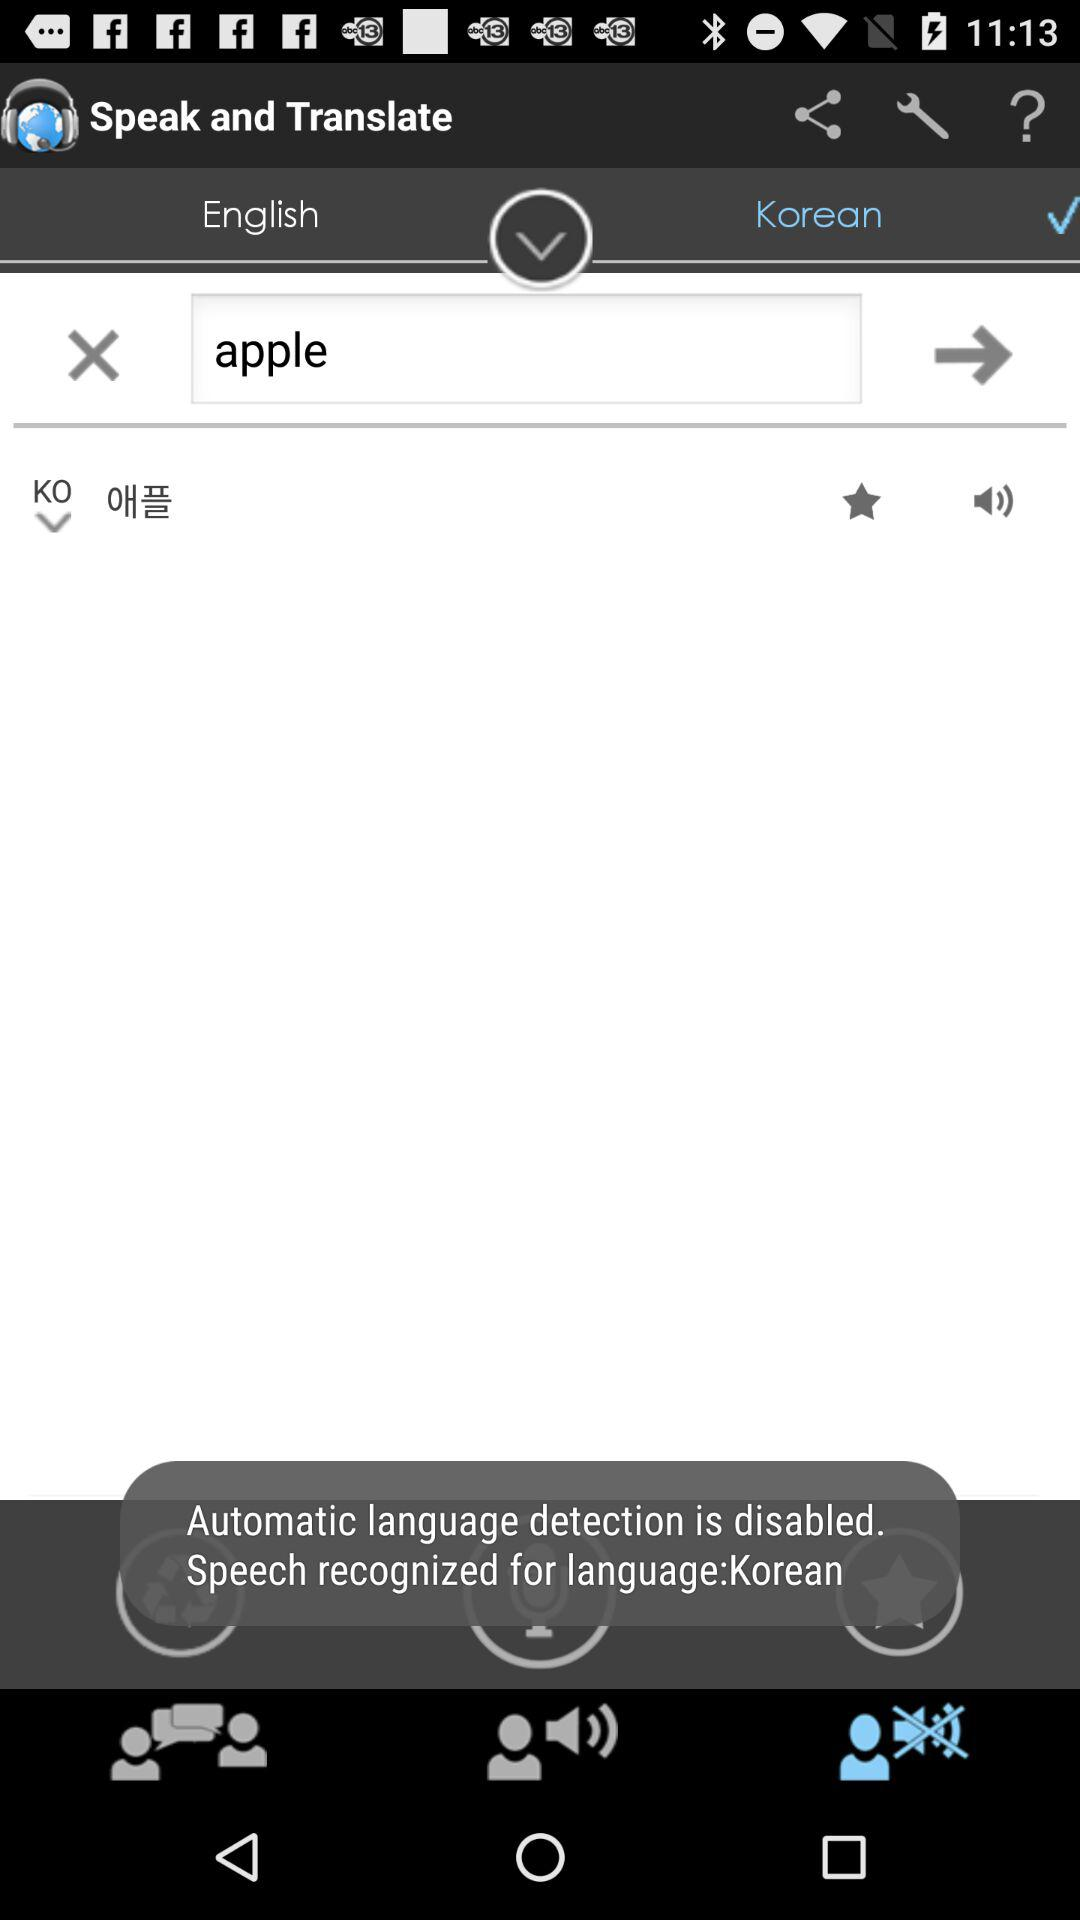How many times can the word be repeated in Korean?
When the provided information is insufficient, respond with <no answer>. <no answer> 